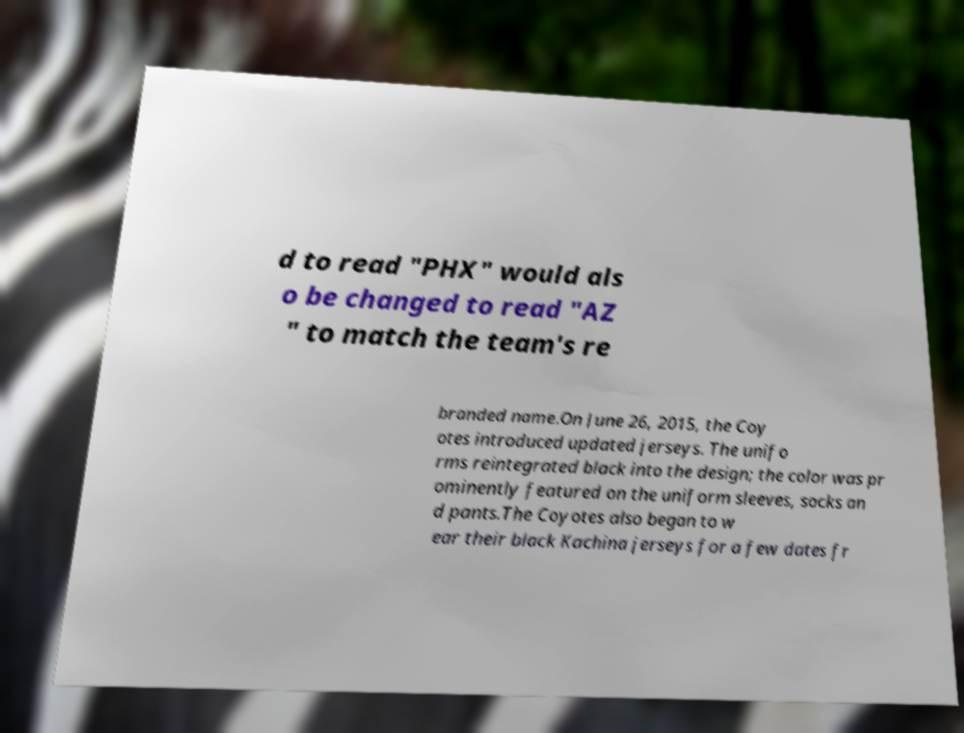Please identify and transcribe the text found in this image. d to read "PHX" would als o be changed to read "AZ " to match the team's re branded name.On June 26, 2015, the Coy otes introduced updated jerseys. The unifo rms reintegrated black into the design; the color was pr ominently featured on the uniform sleeves, socks an d pants.The Coyotes also began to w ear their black Kachina jerseys for a few dates fr 